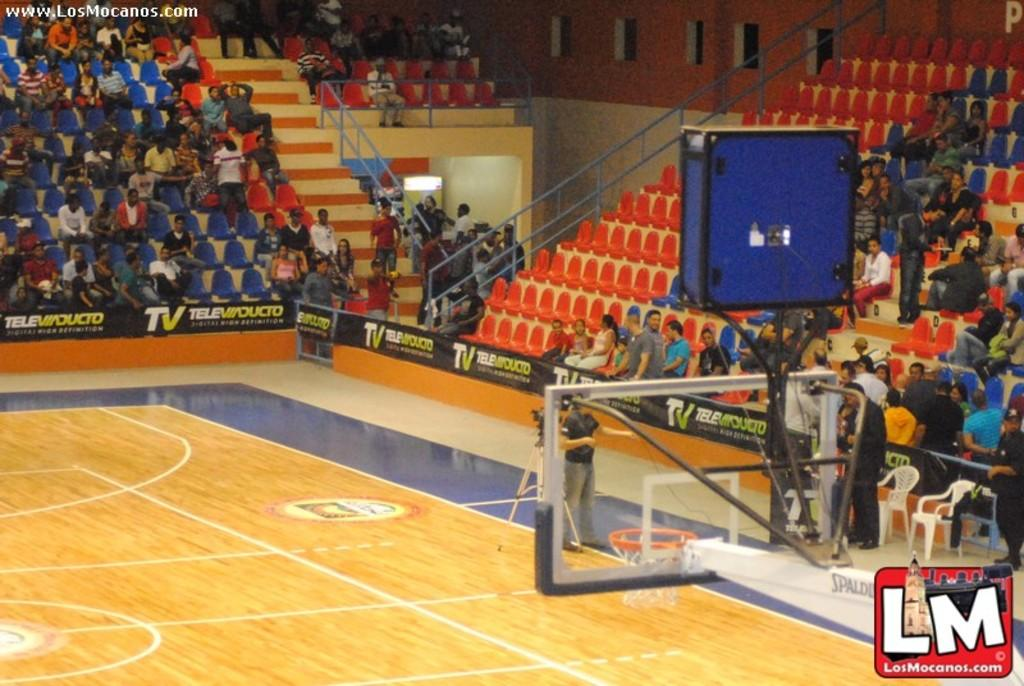<image>
Relay a brief, clear account of the picture shown. A watermark of LM is in the bottom right hand corner of a picture of a basketball court. 